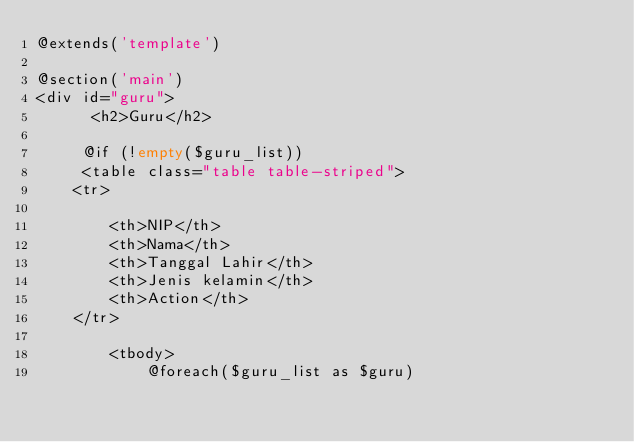<code> <loc_0><loc_0><loc_500><loc_500><_PHP_>@extends('template')

@section('main')
<div id="guru">
      <h2>Guru</h2>

     @if (!empty($guru_list))
     <table class="table table-striped">
    <tr>
        
        <th>NIP</th>
        <th>Nama</th>
        <th>Tanggal Lahir</th>
        <th>Jenis kelamin</th>
        <th>Action</th>
    </tr>

        <tbody>
            @foreach($guru_list as $guru)</code> 